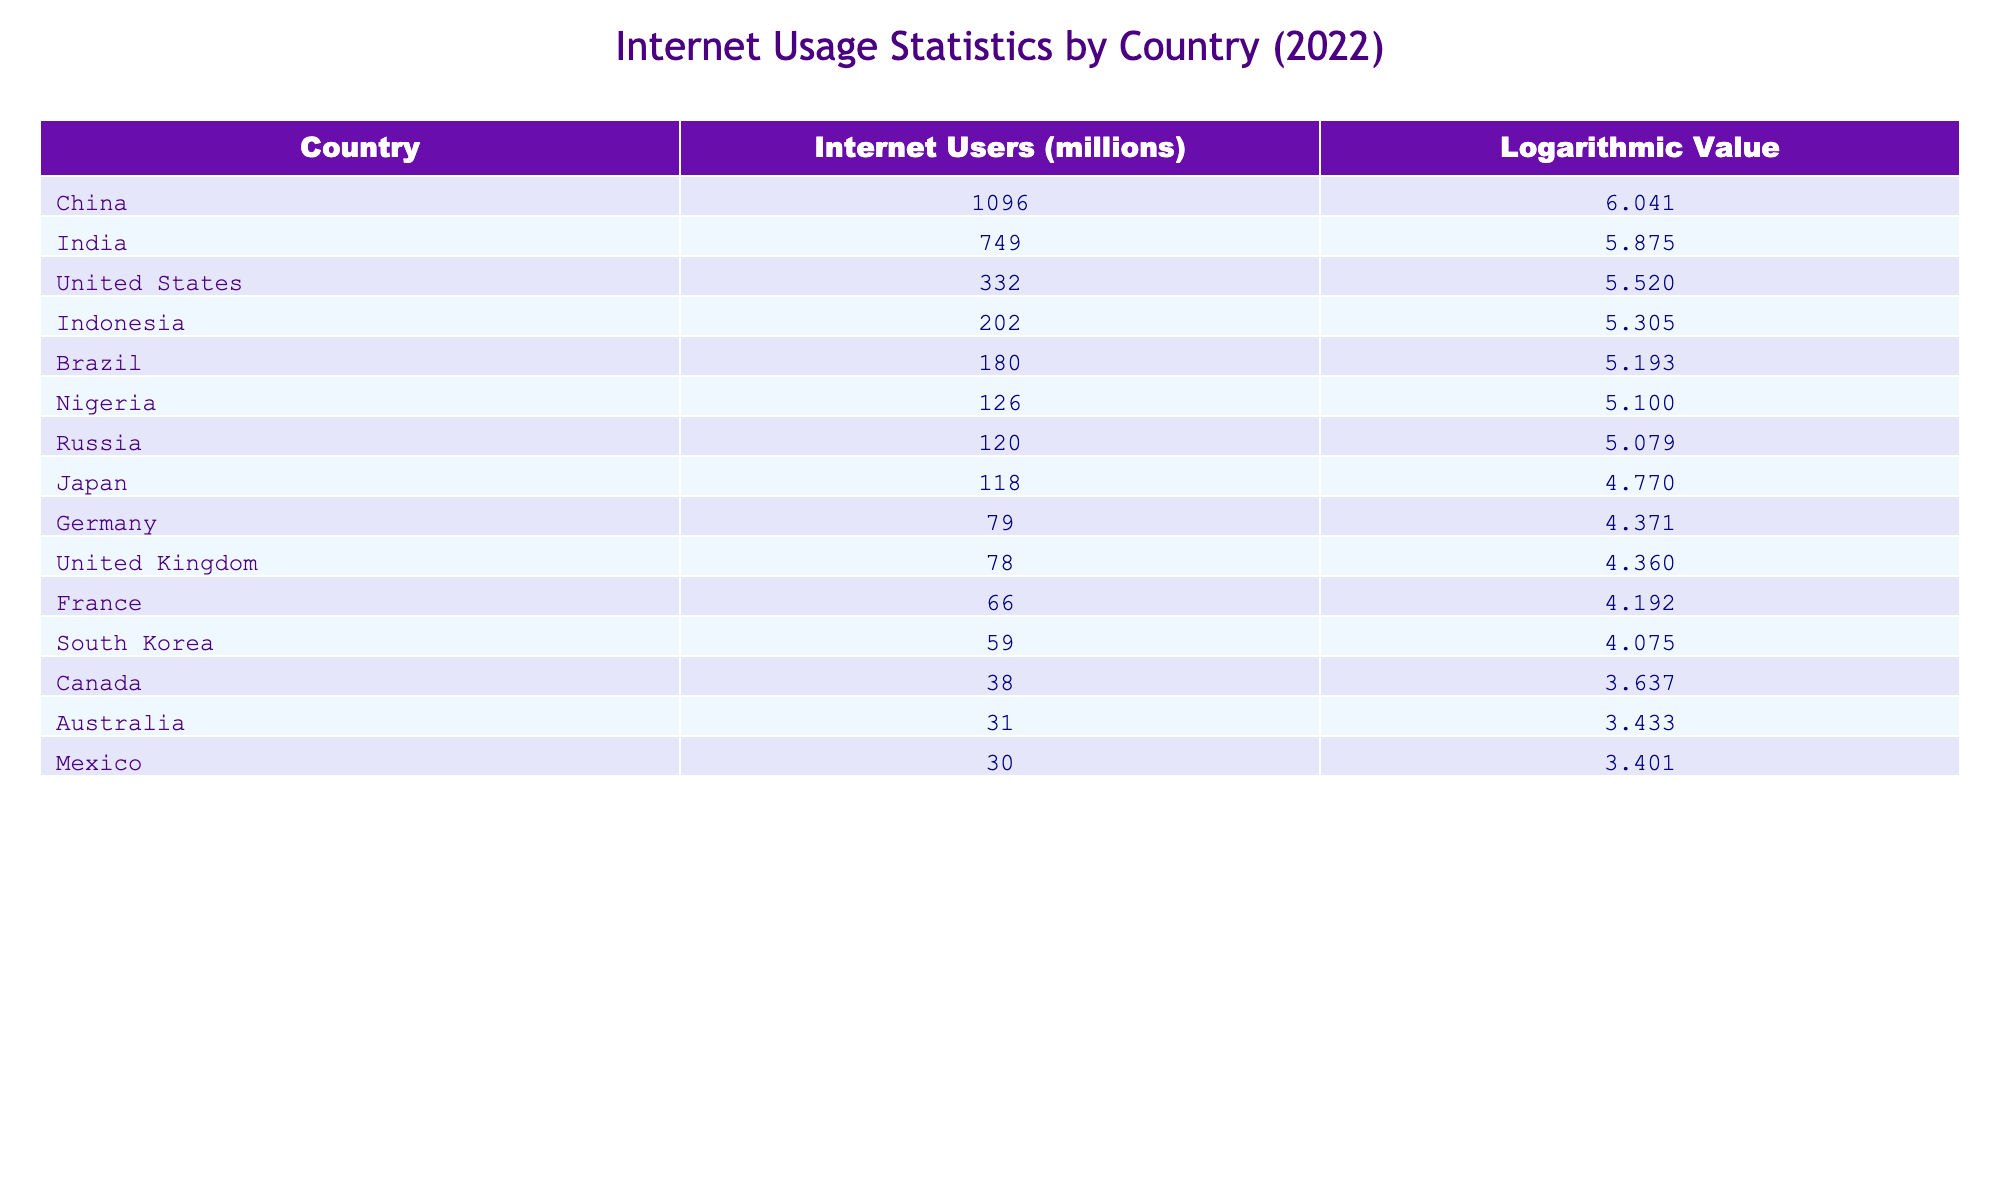What country has the highest number of internet users? The table lists the number of internet users for various countries. By checking the values in the "Internet Users (millions)" column, China has the highest number at 1096 million.
Answer: China Which country has fewer internet users, Nigeria or Brazil? Looking at the values for Nigeria (126 million) and Brazil (180 million), Nigeria has fewer internet users than Brazil.
Answer: Nigeria What is the logarithmic value for Indonesia's internet users? The table displays the logarithmic value corresponding to Indonesia's internet users, which is 5.305. This can be found in the "Logarithmic Value" column next to Indonesia.
Answer: 5.305 How many total internet users are there for the top three countries combined? The top three countries by internet users are China (1096 million), India (749 million), and the United States (332 million). Adding these together gives 1096 + 749 + 332 = 2177 million.
Answer: 2177 million Is the statement "France has more internet users than the United Kingdom" true? According to the table, France has 66 million internet users, while the United Kingdom has 78 million. Since 66 million is less than 78 million, the statement is false.
Answer: No What is the difference in internet users between the United States and Germany? The number of internet users in the United States is 332 million and in Germany, it is 79 million. The difference is calculated as 332 - 79 = 253 million.
Answer: 253 million What is the average number of internet users for the countries listed with more than 100 million users? The countries with more than 100 million users are China (1096), India (749), Indonesia (202), Nigeria (126), and Russia (120), making a total of 1096 + 749 + 202 + 126 + 120 = 2293 million. There are 5 countries, so the average is 2293 / 5 = 458.6 million.
Answer: 458.6 million Which country has the lowest logarithmic value among the listed countries? By reviewing the "Logarithmic Value" column, Australia has the lowest logarithmic value at 3.433.
Answer: Australia 